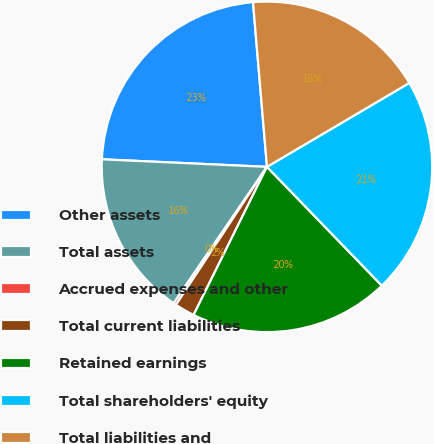<chart> <loc_0><loc_0><loc_500><loc_500><pie_chart><fcel>Other assets<fcel>Total assets<fcel>Accrued expenses and other<fcel>Total current liabilities<fcel>Retained earnings<fcel>Total shareholders' equity<fcel>Total liabilities and<nl><fcel>22.93%<fcel>16.18%<fcel>0.27%<fcel>1.96%<fcel>19.56%<fcel>21.25%<fcel>17.87%<nl></chart> 